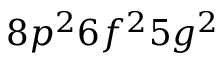Convert formula to latex. <formula><loc_0><loc_0><loc_500><loc_500>8 p ^ { 2 } 6 f ^ { 2 } 5 g ^ { 2 }</formula> 